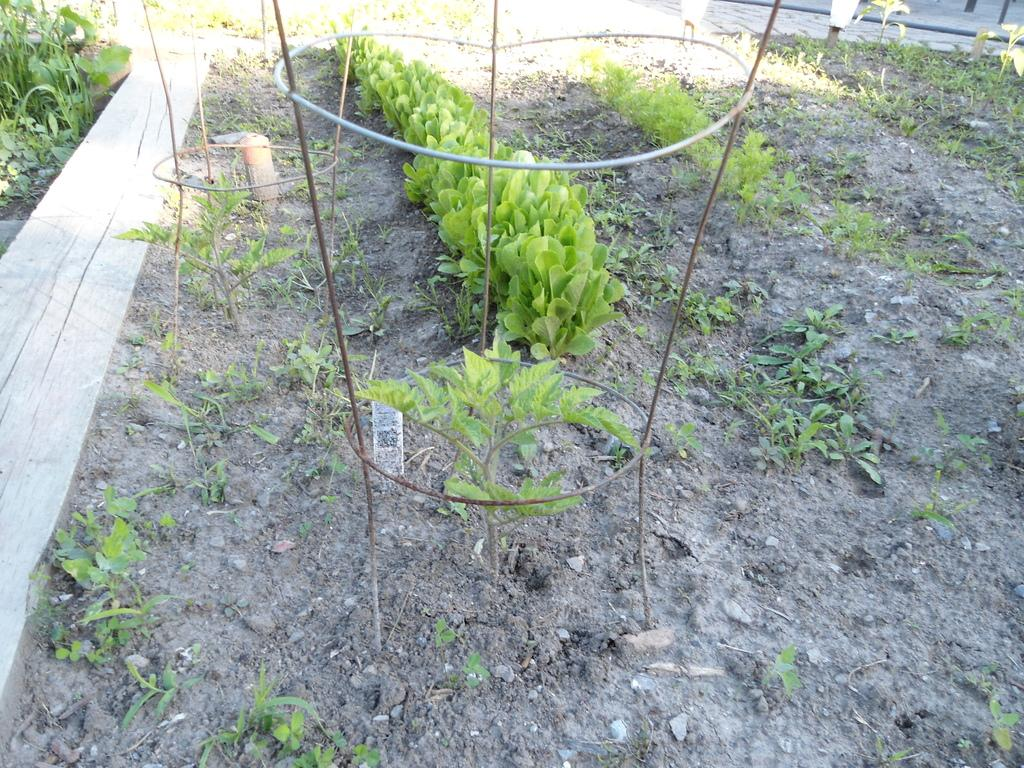What type of living organisms can be seen in the image? Plants can be seen in the image. What color are the plants in the image? The plants are green in color. What else is visible in the image besides the plants? There are rods visible in the image. What type of bone can be seen in the image? There is no bone present in the image; it features plants and rods. Can you tell me how many drawers are visible in the image? There are no drawers present in the image. 